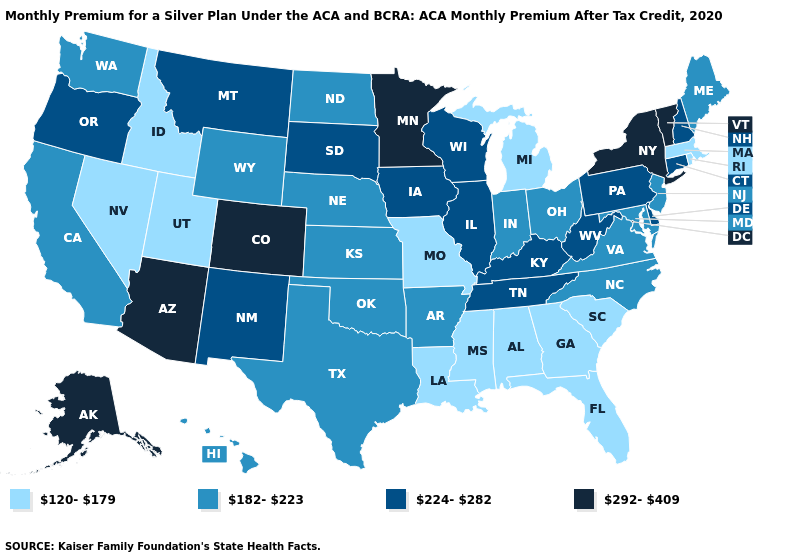Among the states that border Kansas , which have the lowest value?
Write a very short answer. Missouri. What is the lowest value in states that border Pennsylvania?
Short answer required. 182-223. Does Indiana have the highest value in the USA?
Write a very short answer. No. Among the states that border Washington , which have the highest value?
Short answer required. Oregon. What is the value of Montana?
Write a very short answer. 224-282. Name the states that have a value in the range 292-409?
Quick response, please. Alaska, Arizona, Colorado, Minnesota, New York, Vermont. What is the highest value in the USA?
Be succinct. 292-409. What is the value of North Dakota?
Give a very brief answer. 182-223. Name the states that have a value in the range 120-179?
Answer briefly. Alabama, Florida, Georgia, Idaho, Louisiana, Massachusetts, Michigan, Mississippi, Missouri, Nevada, Rhode Island, South Carolina, Utah. Which states hav the highest value in the Northeast?
Answer briefly. New York, Vermont. What is the value of Kentucky?
Write a very short answer. 224-282. Among the states that border Minnesota , does North Dakota have the highest value?
Be succinct. No. Which states have the lowest value in the South?
Short answer required. Alabama, Florida, Georgia, Louisiana, Mississippi, South Carolina. Is the legend a continuous bar?
Keep it brief. No. What is the value of Michigan?
Answer briefly. 120-179. 